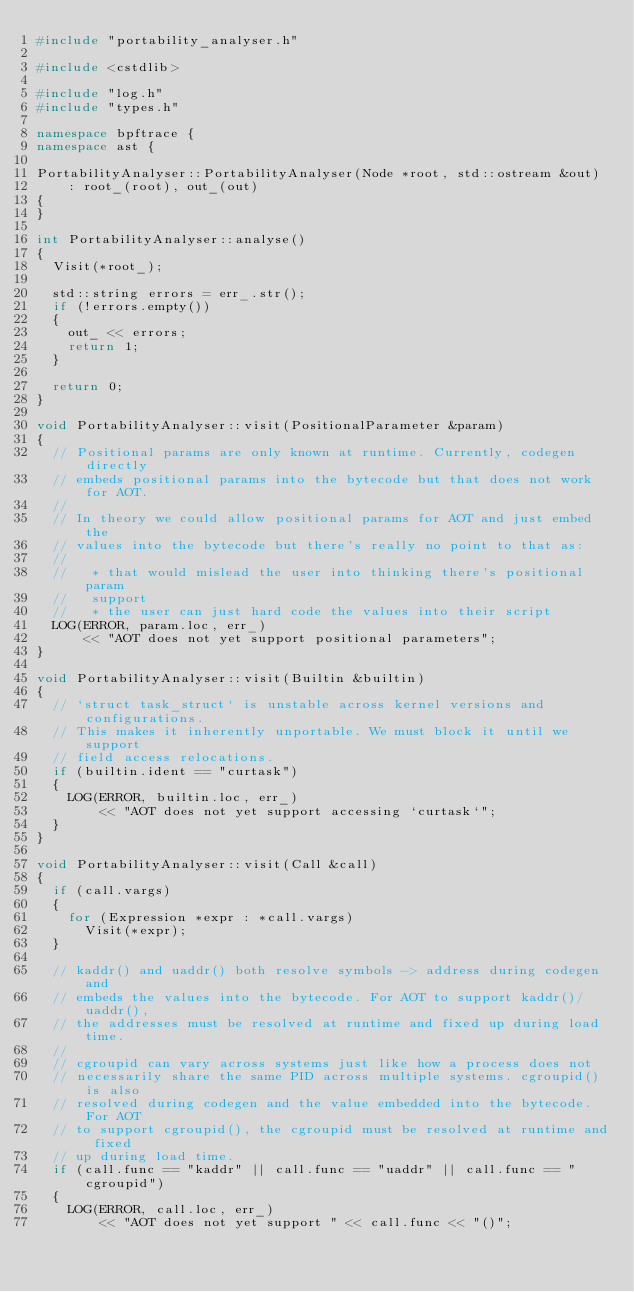<code> <loc_0><loc_0><loc_500><loc_500><_C++_>#include "portability_analyser.h"

#include <cstdlib>

#include "log.h"
#include "types.h"

namespace bpftrace {
namespace ast {

PortabilityAnalyser::PortabilityAnalyser(Node *root, std::ostream &out)
    : root_(root), out_(out)
{
}

int PortabilityAnalyser::analyse()
{
  Visit(*root_);

  std::string errors = err_.str();
  if (!errors.empty())
  {
    out_ << errors;
    return 1;
  }

  return 0;
}

void PortabilityAnalyser::visit(PositionalParameter &param)
{
  // Positional params are only known at runtime. Currently, codegen directly
  // embeds positional params into the bytecode but that does not work for AOT.
  //
  // In theory we could allow positional params for AOT and just embed the
  // values into the bytecode but there's really no point to that as:
  //
  //   * that would mislead the user into thinking there's positional param
  //   support
  //   * the user can just hard code the values into their script
  LOG(ERROR, param.loc, err_)
      << "AOT does not yet support positional parameters";
}

void PortabilityAnalyser::visit(Builtin &builtin)
{
  // `struct task_struct` is unstable across kernel versions and configurations.
  // This makes it inherently unportable. We must block it until we support
  // field access relocations.
  if (builtin.ident == "curtask")
  {
    LOG(ERROR, builtin.loc, err_)
        << "AOT does not yet support accessing `curtask`";
  }
}

void PortabilityAnalyser::visit(Call &call)
{
  if (call.vargs)
  {
    for (Expression *expr : *call.vargs)
      Visit(*expr);
  }

  // kaddr() and uaddr() both resolve symbols -> address during codegen and
  // embeds the values into the bytecode. For AOT to support kaddr()/uaddr(),
  // the addresses must be resolved at runtime and fixed up during load time.
  //
  // cgroupid can vary across systems just like how a process does not
  // necessarily share the same PID across multiple systems. cgroupid() is also
  // resolved during codegen and the value embedded into the bytecode.  For AOT
  // to support cgroupid(), the cgroupid must be resolved at runtime and fixed
  // up during load time.
  if (call.func == "kaddr" || call.func == "uaddr" || call.func == "cgroupid")
  {
    LOG(ERROR, call.loc, err_)
        << "AOT does not yet support " << call.func << "()";</code> 